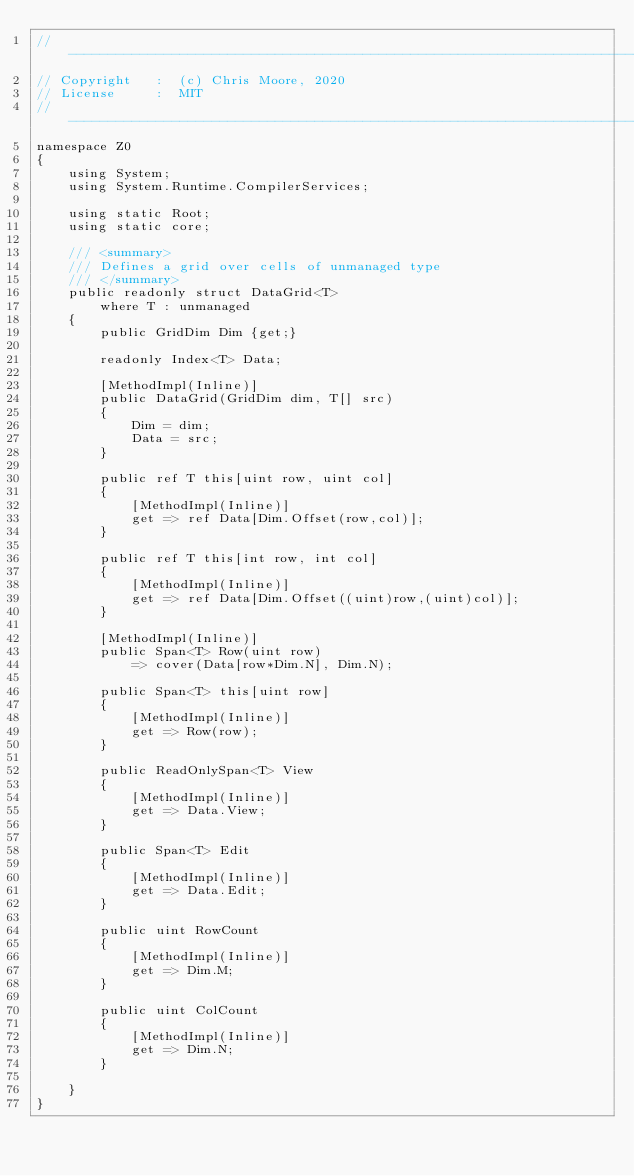Convert code to text. <code><loc_0><loc_0><loc_500><loc_500><_C#_>//-----------------------------------------------------------------------------
// Copyright   :  (c) Chris Moore, 2020
// License     :  MIT
//-----------------------------------------------------------------------------
namespace Z0
{
    using System;
    using System.Runtime.CompilerServices;

    using static Root;
    using static core;

    /// <summary>
    /// Defines a grid over cells of unmanaged type
    /// </summary>
    public readonly struct DataGrid<T>
        where T : unmanaged
    {
        public GridDim Dim {get;}

        readonly Index<T> Data;

        [MethodImpl(Inline)]
        public DataGrid(GridDim dim, T[] src)
        {
            Dim = dim;
            Data = src;
        }

        public ref T this[uint row, uint col]
        {
            [MethodImpl(Inline)]
            get => ref Data[Dim.Offset(row,col)];
        }

        public ref T this[int row, int col]
        {
            [MethodImpl(Inline)]
            get => ref Data[Dim.Offset((uint)row,(uint)col)];
        }

        [MethodImpl(Inline)]
        public Span<T> Row(uint row)
            => cover(Data[row*Dim.N], Dim.N);

        public Span<T> this[uint row]
        {
            [MethodImpl(Inline)]
            get => Row(row);
        }

        public ReadOnlySpan<T> View
        {
            [MethodImpl(Inline)]
            get => Data.View;
        }

        public Span<T> Edit
        {
            [MethodImpl(Inline)]
            get => Data.Edit;
        }

        public uint RowCount
        {
            [MethodImpl(Inline)]
            get => Dim.M;
        }

        public uint ColCount
        {
            [MethodImpl(Inline)]
            get => Dim.N;
        }

    }
}</code> 